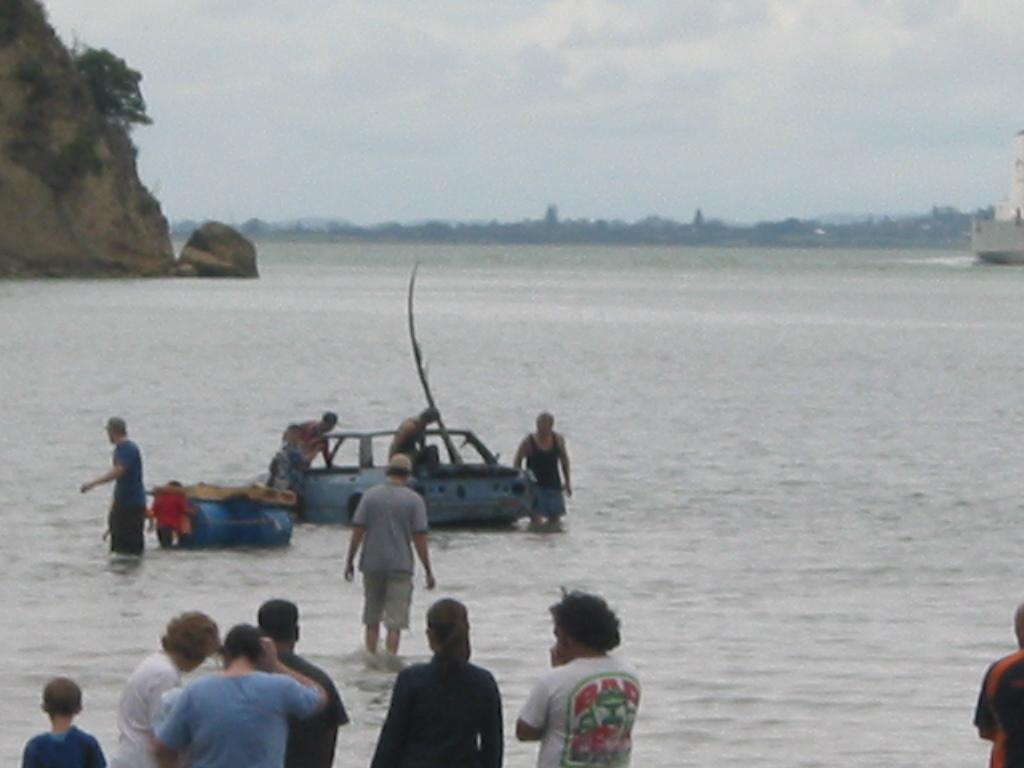What is located in the middle of the image? There is water and a car in the middle of the image. What else can be seen in the image besides the water and car? There are people at the bottom of the image. What is visible at the top of the image? The sky is visible at the top of the image. Where is the girl sitting and eating cabbage in the image? There is no girl or cabbage present in the image. 